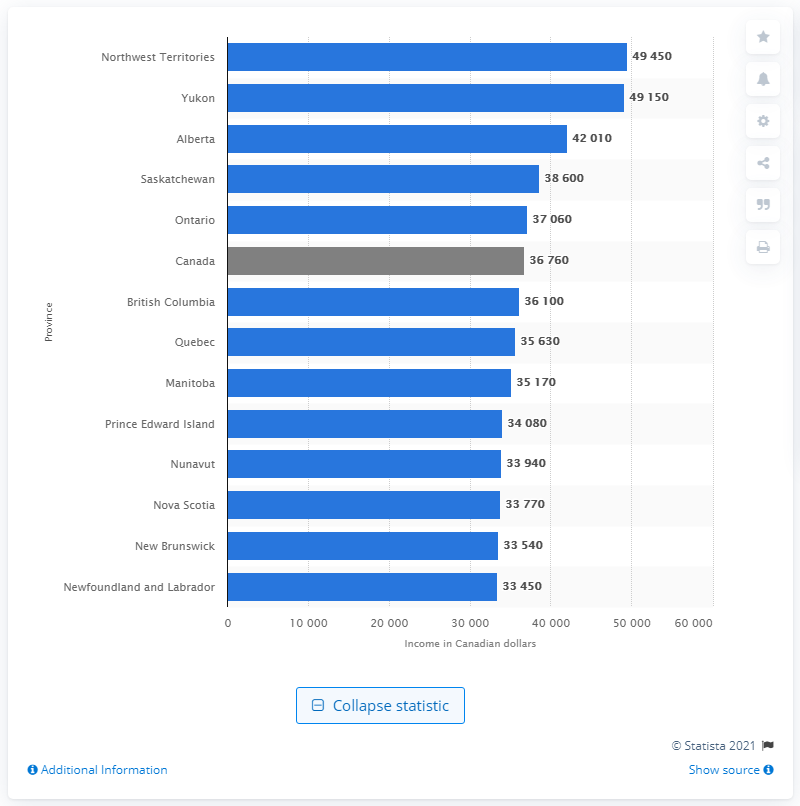Draw attention to some important aspects in this diagram. In 2018, Canada had the highest median income among all countries. 